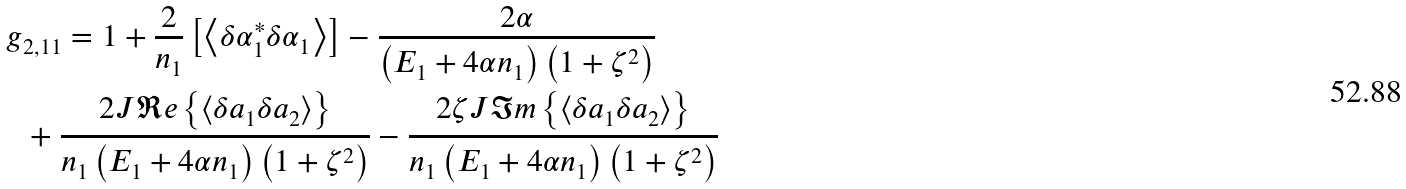<formula> <loc_0><loc_0><loc_500><loc_500>g & _ { 2 , 1 1 } = 1 + \frac { 2 } { n _ { 1 } } \left [ \left < \delta \alpha _ { 1 } ^ { * } \delta \alpha _ { 1 } \right > \right ] - \frac { 2 \alpha } { \left ( E _ { 1 } + 4 \alpha n _ { 1 } \right ) \left ( 1 + \zeta ^ { 2 } \right ) } \\ & + \frac { 2 J \Re e \left \{ \left < \delta a _ { 1 } \delta a _ { 2 } \right > \right \} } { n _ { 1 } \left ( E _ { 1 } + 4 \alpha n _ { 1 } \right ) \left ( 1 + \zeta ^ { 2 } \right ) } - \frac { 2 \zeta J \Im m \left \{ \left < \delta a _ { 1 } \delta a _ { 2 } \right > \right \} } { n _ { 1 } \left ( E _ { 1 } + 4 \alpha n _ { 1 } \right ) \left ( 1 + \zeta ^ { 2 } \right ) }</formula> 